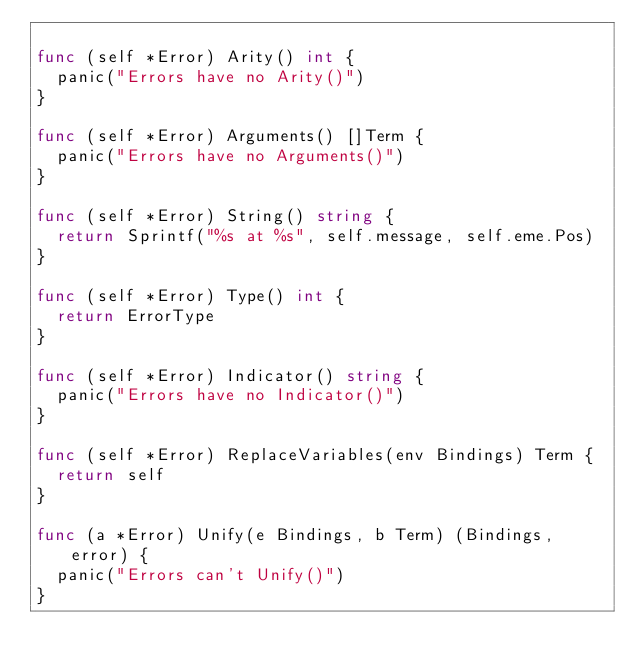<code> <loc_0><loc_0><loc_500><loc_500><_Go_>
func (self *Error) Arity() int {
	panic("Errors have no Arity()")
}

func (self *Error) Arguments() []Term {
	panic("Errors have no Arguments()")
}

func (self *Error) String() string {
	return Sprintf("%s at %s", self.message, self.eme.Pos)
}

func (self *Error) Type() int {
	return ErrorType
}

func (self *Error) Indicator() string {
	panic("Errors have no Indicator()")
}

func (self *Error) ReplaceVariables(env Bindings) Term {
	return self
}

func (a *Error) Unify(e Bindings, b Term) (Bindings, error) {
	panic("Errors can't Unify()")
}
</code> 